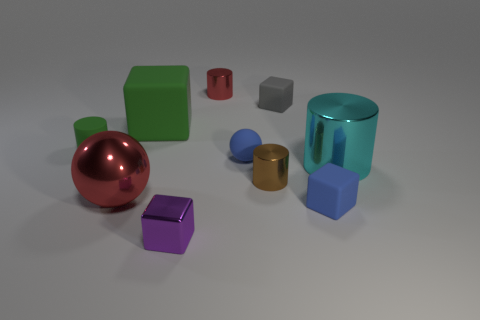Does the red thing that is behind the matte cylinder have the same size as the green cylinder?
Keep it short and to the point. Yes. What number of red things have the same shape as the purple thing?
Offer a very short reply. 0. The cyan thing that is the same material as the big red ball is what size?
Your answer should be very brief. Large. Are there an equal number of small green rubber cylinders that are left of the purple thing and tiny yellow matte things?
Ensure brevity in your answer.  No. Is the big cylinder the same color as the large matte block?
Provide a succinct answer. No. Do the rubber thing that is in front of the large cyan shiny cylinder and the blue rubber thing left of the blue cube have the same shape?
Offer a very short reply. No. There is a cyan object that is the same shape as the small red shiny thing; what is its material?
Your response must be concise. Metal. What is the color of the tiny rubber thing that is both on the right side of the green cylinder and behind the tiny matte ball?
Offer a very short reply. Gray. Are there any small gray rubber objects on the left side of the large thing that is behind the small blue thing that is left of the tiny gray object?
Offer a terse response. No. How many things are either gray rubber cylinders or tiny brown things?
Your response must be concise. 1. 